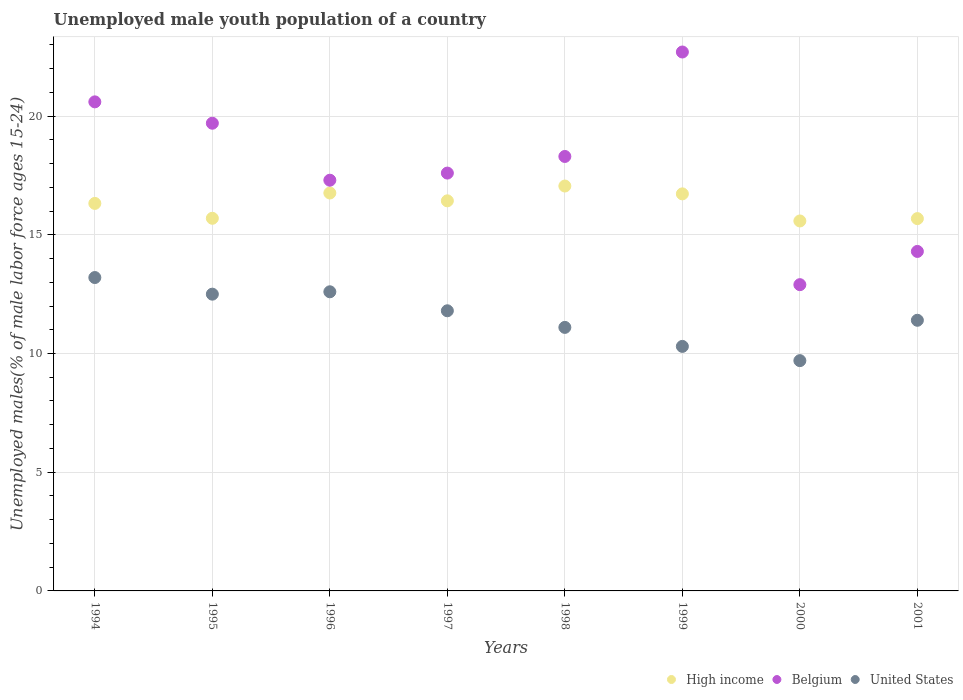How many different coloured dotlines are there?
Ensure brevity in your answer.  3. What is the percentage of unemployed male youth population in High income in 1996?
Make the answer very short. 16.76. Across all years, what is the maximum percentage of unemployed male youth population in Belgium?
Your response must be concise. 22.7. Across all years, what is the minimum percentage of unemployed male youth population in High income?
Your answer should be very brief. 15.58. In which year was the percentage of unemployed male youth population in Belgium minimum?
Your response must be concise. 2000. What is the total percentage of unemployed male youth population in United States in the graph?
Ensure brevity in your answer.  92.6. What is the difference between the percentage of unemployed male youth population in Belgium in 1994 and that in 2001?
Ensure brevity in your answer.  6.3. What is the difference between the percentage of unemployed male youth population in United States in 1995 and the percentage of unemployed male youth population in Belgium in 1996?
Ensure brevity in your answer.  -4.8. What is the average percentage of unemployed male youth population in High income per year?
Your answer should be compact. 16.28. In the year 1994, what is the difference between the percentage of unemployed male youth population in United States and percentage of unemployed male youth population in Belgium?
Provide a succinct answer. -7.4. What is the ratio of the percentage of unemployed male youth population in High income in 1994 to that in 1996?
Your answer should be compact. 0.97. What is the difference between the highest and the second highest percentage of unemployed male youth population in High income?
Give a very brief answer. 0.29. What is the difference between the highest and the lowest percentage of unemployed male youth population in Belgium?
Give a very brief answer. 9.8. In how many years, is the percentage of unemployed male youth population in United States greater than the average percentage of unemployed male youth population in United States taken over all years?
Your response must be concise. 4. Is the sum of the percentage of unemployed male youth population in Belgium in 1996 and 2001 greater than the maximum percentage of unemployed male youth population in High income across all years?
Make the answer very short. Yes. Is the percentage of unemployed male youth population in Belgium strictly less than the percentage of unemployed male youth population in United States over the years?
Offer a terse response. No. How many dotlines are there?
Give a very brief answer. 3. How many years are there in the graph?
Give a very brief answer. 8. What is the difference between two consecutive major ticks on the Y-axis?
Your response must be concise. 5. Are the values on the major ticks of Y-axis written in scientific E-notation?
Your response must be concise. No. What is the title of the graph?
Offer a very short reply. Unemployed male youth population of a country. What is the label or title of the Y-axis?
Your response must be concise. Unemployed males(% of male labor force ages 15-24). What is the Unemployed males(% of male labor force ages 15-24) of High income in 1994?
Offer a terse response. 16.32. What is the Unemployed males(% of male labor force ages 15-24) of Belgium in 1994?
Your response must be concise. 20.6. What is the Unemployed males(% of male labor force ages 15-24) in United States in 1994?
Your answer should be compact. 13.2. What is the Unemployed males(% of male labor force ages 15-24) in High income in 1995?
Give a very brief answer. 15.7. What is the Unemployed males(% of male labor force ages 15-24) in Belgium in 1995?
Make the answer very short. 19.7. What is the Unemployed males(% of male labor force ages 15-24) of United States in 1995?
Make the answer very short. 12.5. What is the Unemployed males(% of male labor force ages 15-24) in High income in 1996?
Keep it short and to the point. 16.76. What is the Unemployed males(% of male labor force ages 15-24) in Belgium in 1996?
Provide a succinct answer. 17.3. What is the Unemployed males(% of male labor force ages 15-24) of United States in 1996?
Offer a very short reply. 12.6. What is the Unemployed males(% of male labor force ages 15-24) of High income in 1997?
Offer a terse response. 16.43. What is the Unemployed males(% of male labor force ages 15-24) in Belgium in 1997?
Ensure brevity in your answer.  17.6. What is the Unemployed males(% of male labor force ages 15-24) in United States in 1997?
Your answer should be compact. 11.8. What is the Unemployed males(% of male labor force ages 15-24) in High income in 1998?
Provide a succinct answer. 17.05. What is the Unemployed males(% of male labor force ages 15-24) of Belgium in 1998?
Your answer should be compact. 18.3. What is the Unemployed males(% of male labor force ages 15-24) of United States in 1998?
Offer a terse response. 11.1. What is the Unemployed males(% of male labor force ages 15-24) of High income in 1999?
Make the answer very short. 16.72. What is the Unemployed males(% of male labor force ages 15-24) of Belgium in 1999?
Give a very brief answer. 22.7. What is the Unemployed males(% of male labor force ages 15-24) of United States in 1999?
Your response must be concise. 10.3. What is the Unemployed males(% of male labor force ages 15-24) of High income in 2000?
Make the answer very short. 15.58. What is the Unemployed males(% of male labor force ages 15-24) of Belgium in 2000?
Offer a terse response. 12.9. What is the Unemployed males(% of male labor force ages 15-24) of United States in 2000?
Your response must be concise. 9.7. What is the Unemployed males(% of male labor force ages 15-24) of High income in 2001?
Your answer should be compact. 15.68. What is the Unemployed males(% of male labor force ages 15-24) of Belgium in 2001?
Ensure brevity in your answer.  14.3. What is the Unemployed males(% of male labor force ages 15-24) in United States in 2001?
Your response must be concise. 11.4. Across all years, what is the maximum Unemployed males(% of male labor force ages 15-24) of High income?
Give a very brief answer. 17.05. Across all years, what is the maximum Unemployed males(% of male labor force ages 15-24) of Belgium?
Give a very brief answer. 22.7. Across all years, what is the maximum Unemployed males(% of male labor force ages 15-24) of United States?
Your answer should be very brief. 13.2. Across all years, what is the minimum Unemployed males(% of male labor force ages 15-24) in High income?
Your response must be concise. 15.58. Across all years, what is the minimum Unemployed males(% of male labor force ages 15-24) in Belgium?
Keep it short and to the point. 12.9. Across all years, what is the minimum Unemployed males(% of male labor force ages 15-24) in United States?
Provide a succinct answer. 9.7. What is the total Unemployed males(% of male labor force ages 15-24) in High income in the graph?
Provide a succinct answer. 130.26. What is the total Unemployed males(% of male labor force ages 15-24) of Belgium in the graph?
Offer a very short reply. 143.4. What is the total Unemployed males(% of male labor force ages 15-24) of United States in the graph?
Ensure brevity in your answer.  92.6. What is the difference between the Unemployed males(% of male labor force ages 15-24) of High income in 1994 and that in 1995?
Your answer should be very brief. 0.63. What is the difference between the Unemployed males(% of male labor force ages 15-24) of United States in 1994 and that in 1995?
Provide a short and direct response. 0.7. What is the difference between the Unemployed males(% of male labor force ages 15-24) of High income in 1994 and that in 1996?
Give a very brief answer. -0.44. What is the difference between the Unemployed males(% of male labor force ages 15-24) in High income in 1994 and that in 1997?
Your response must be concise. -0.11. What is the difference between the Unemployed males(% of male labor force ages 15-24) of United States in 1994 and that in 1997?
Ensure brevity in your answer.  1.4. What is the difference between the Unemployed males(% of male labor force ages 15-24) in High income in 1994 and that in 1998?
Provide a succinct answer. -0.73. What is the difference between the Unemployed males(% of male labor force ages 15-24) of Belgium in 1994 and that in 1998?
Provide a succinct answer. 2.3. What is the difference between the Unemployed males(% of male labor force ages 15-24) of United States in 1994 and that in 1998?
Your answer should be very brief. 2.1. What is the difference between the Unemployed males(% of male labor force ages 15-24) in High income in 1994 and that in 1999?
Provide a short and direct response. -0.4. What is the difference between the Unemployed males(% of male labor force ages 15-24) in Belgium in 1994 and that in 1999?
Give a very brief answer. -2.1. What is the difference between the Unemployed males(% of male labor force ages 15-24) in High income in 1994 and that in 2000?
Keep it short and to the point. 0.74. What is the difference between the Unemployed males(% of male labor force ages 15-24) in United States in 1994 and that in 2000?
Make the answer very short. 3.5. What is the difference between the Unemployed males(% of male labor force ages 15-24) in High income in 1994 and that in 2001?
Make the answer very short. 0.64. What is the difference between the Unemployed males(% of male labor force ages 15-24) in Belgium in 1994 and that in 2001?
Your answer should be compact. 6.3. What is the difference between the Unemployed males(% of male labor force ages 15-24) of United States in 1994 and that in 2001?
Your answer should be very brief. 1.8. What is the difference between the Unemployed males(% of male labor force ages 15-24) of High income in 1995 and that in 1996?
Make the answer very short. -1.07. What is the difference between the Unemployed males(% of male labor force ages 15-24) of United States in 1995 and that in 1996?
Your response must be concise. -0.1. What is the difference between the Unemployed males(% of male labor force ages 15-24) in High income in 1995 and that in 1997?
Make the answer very short. -0.74. What is the difference between the Unemployed males(% of male labor force ages 15-24) of Belgium in 1995 and that in 1997?
Give a very brief answer. 2.1. What is the difference between the Unemployed males(% of male labor force ages 15-24) in High income in 1995 and that in 1998?
Ensure brevity in your answer.  -1.36. What is the difference between the Unemployed males(% of male labor force ages 15-24) in United States in 1995 and that in 1998?
Give a very brief answer. 1.4. What is the difference between the Unemployed males(% of male labor force ages 15-24) of High income in 1995 and that in 1999?
Your answer should be very brief. -1.03. What is the difference between the Unemployed males(% of male labor force ages 15-24) in Belgium in 1995 and that in 1999?
Keep it short and to the point. -3. What is the difference between the Unemployed males(% of male labor force ages 15-24) of United States in 1995 and that in 1999?
Give a very brief answer. 2.2. What is the difference between the Unemployed males(% of male labor force ages 15-24) in High income in 1995 and that in 2000?
Give a very brief answer. 0.11. What is the difference between the Unemployed males(% of male labor force ages 15-24) of Belgium in 1995 and that in 2000?
Your answer should be compact. 6.8. What is the difference between the Unemployed males(% of male labor force ages 15-24) of High income in 1995 and that in 2001?
Ensure brevity in your answer.  0.01. What is the difference between the Unemployed males(% of male labor force ages 15-24) of United States in 1995 and that in 2001?
Keep it short and to the point. 1.1. What is the difference between the Unemployed males(% of male labor force ages 15-24) of High income in 1996 and that in 1997?
Provide a short and direct response. 0.33. What is the difference between the Unemployed males(% of male labor force ages 15-24) of High income in 1996 and that in 1998?
Offer a very short reply. -0.29. What is the difference between the Unemployed males(% of male labor force ages 15-24) of United States in 1996 and that in 1998?
Offer a terse response. 1.5. What is the difference between the Unemployed males(% of male labor force ages 15-24) in High income in 1996 and that in 1999?
Provide a short and direct response. 0.04. What is the difference between the Unemployed males(% of male labor force ages 15-24) in Belgium in 1996 and that in 1999?
Provide a succinct answer. -5.4. What is the difference between the Unemployed males(% of male labor force ages 15-24) of United States in 1996 and that in 1999?
Make the answer very short. 2.3. What is the difference between the Unemployed males(% of male labor force ages 15-24) in High income in 1996 and that in 2000?
Your response must be concise. 1.18. What is the difference between the Unemployed males(% of male labor force ages 15-24) in Belgium in 1996 and that in 2000?
Keep it short and to the point. 4.4. What is the difference between the Unemployed males(% of male labor force ages 15-24) of High income in 1996 and that in 2001?
Give a very brief answer. 1.08. What is the difference between the Unemployed males(% of male labor force ages 15-24) in Belgium in 1996 and that in 2001?
Provide a short and direct response. 3. What is the difference between the Unemployed males(% of male labor force ages 15-24) in United States in 1996 and that in 2001?
Your response must be concise. 1.2. What is the difference between the Unemployed males(% of male labor force ages 15-24) in High income in 1997 and that in 1998?
Your answer should be very brief. -0.62. What is the difference between the Unemployed males(% of male labor force ages 15-24) of United States in 1997 and that in 1998?
Your answer should be very brief. 0.7. What is the difference between the Unemployed males(% of male labor force ages 15-24) in High income in 1997 and that in 1999?
Give a very brief answer. -0.29. What is the difference between the Unemployed males(% of male labor force ages 15-24) of High income in 1997 and that in 2000?
Your answer should be very brief. 0.85. What is the difference between the Unemployed males(% of male labor force ages 15-24) of Belgium in 1997 and that in 2000?
Your answer should be compact. 4.7. What is the difference between the Unemployed males(% of male labor force ages 15-24) of High income in 1997 and that in 2001?
Provide a short and direct response. 0.75. What is the difference between the Unemployed males(% of male labor force ages 15-24) in Belgium in 1997 and that in 2001?
Make the answer very short. 3.3. What is the difference between the Unemployed males(% of male labor force ages 15-24) in High income in 1998 and that in 1999?
Ensure brevity in your answer.  0.33. What is the difference between the Unemployed males(% of male labor force ages 15-24) of Belgium in 1998 and that in 1999?
Your answer should be very brief. -4.4. What is the difference between the Unemployed males(% of male labor force ages 15-24) in High income in 1998 and that in 2000?
Keep it short and to the point. 1.47. What is the difference between the Unemployed males(% of male labor force ages 15-24) of High income in 1998 and that in 2001?
Make the answer very short. 1.37. What is the difference between the Unemployed males(% of male labor force ages 15-24) of United States in 1998 and that in 2001?
Offer a very short reply. -0.3. What is the difference between the Unemployed males(% of male labor force ages 15-24) of High income in 1999 and that in 2000?
Offer a terse response. 1.14. What is the difference between the Unemployed males(% of male labor force ages 15-24) of Belgium in 1999 and that in 2000?
Ensure brevity in your answer.  9.8. What is the difference between the Unemployed males(% of male labor force ages 15-24) of United States in 1999 and that in 2000?
Make the answer very short. 0.6. What is the difference between the Unemployed males(% of male labor force ages 15-24) in High income in 1999 and that in 2001?
Your response must be concise. 1.04. What is the difference between the Unemployed males(% of male labor force ages 15-24) of United States in 1999 and that in 2001?
Keep it short and to the point. -1.1. What is the difference between the Unemployed males(% of male labor force ages 15-24) in High income in 2000 and that in 2001?
Provide a short and direct response. -0.1. What is the difference between the Unemployed males(% of male labor force ages 15-24) in United States in 2000 and that in 2001?
Offer a very short reply. -1.7. What is the difference between the Unemployed males(% of male labor force ages 15-24) of High income in 1994 and the Unemployed males(% of male labor force ages 15-24) of Belgium in 1995?
Your answer should be compact. -3.38. What is the difference between the Unemployed males(% of male labor force ages 15-24) of High income in 1994 and the Unemployed males(% of male labor force ages 15-24) of United States in 1995?
Offer a terse response. 3.82. What is the difference between the Unemployed males(% of male labor force ages 15-24) of Belgium in 1994 and the Unemployed males(% of male labor force ages 15-24) of United States in 1995?
Your response must be concise. 8.1. What is the difference between the Unemployed males(% of male labor force ages 15-24) of High income in 1994 and the Unemployed males(% of male labor force ages 15-24) of Belgium in 1996?
Keep it short and to the point. -0.98. What is the difference between the Unemployed males(% of male labor force ages 15-24) in High income in 1994 and the Unemployed males(% of male labor force ages 15-24) in United States in 1996?
Provide a succinct answer. 3.72. What is the difference between the Unemployed males(% of male labor force ages 15-24) of High income in 1994 and the Unemployed males(% of male labor force ages 15-24) of Belgium in 1997?
Offer a terse response. -1.28. What is the difference between the Unemployed males(% of male labor force ages 15-24) of High income in 1994 and the Unemployed males(% of male labor force ages 15-24) of United States in 1997?
Provide a succinct answer. 4.52. What is the difference between the Unemployed males(% of male labor force ages 15-24) in High income in 1994 and the Unemployed males(% of male labor force ages 15-24) in Belgium in 1998?
Offer a terse response. -1.98. What is the difference between the Unemployed males(% of male labor force ages 15-24) in High income in 1994 and the Unemployed males(% of male labor force ages 15-24) in United States in 1998?
Provide a succinct answer. 5.22. What is the difference between the Unemployed males(% of male labor force ages 15-24) of Belgium in 1994 and the Unemployed males(% of male labor force ages 15-24) of United States in 1998?
Provide a succinct answer. 9.5. What is the difference between the Unemployed males(% of male labor force ages 15-24) of High income in 1994 and the Unemployed males(% of male labor force ages 15-24) of Belgium in 1999?
Provide a short and direct response. -6.38. What is the difference between the Unemployed males(% of male labor force ages 15-24) of High income in 1994 and the Unemployed males(% of male labor force ages 15-24) of United States in 1999?
Your response must be concise. 6.02. What is the difference between the Unemployed males(% of male labor force ages 15-24) in High income in 1994 and the Unemployed males(% of male labor force ages 15-24) in Belgium in 2000?
Provide a succinct answer. 3.42. What is the difference between the Unemployed males(% of male labor force ages 15-24) of High income in 1994 and the Unemployed males(% of male labor force ages 15-24) of United States in 2000?
Make the answer very short. 6.62. What is the difference between the Unemployed males(% of male labor force ages 15-24) in High income in 1994 and the Unemployed males(% of male labor force ages 15-24) in Belgium in 2001?
Offer a terse response. 2.02. What is the difference between the Unemployed males(% of male labor force ages 15-24) of High income in 1994 and the Unemployed males(% of male labor force ages 15-24) of United States in 2001?
Your response must be concise. 4.92. What is the difference between the Unemployed males(% of male labor force ages 15-24) in High income in 1995 and the Unemployed males(% of male labor force ages 15-24) in Belgium in 1996?
Your answer should be very brief. -1.6. What is the difference between the Unemployed males(% of male labor force ages 15-24) in High income in 1995 and the Unemployed males(% of male labor force ages 15-24) in United States in 1996?
Keep it short and to the point. 3.1. What is the difference between the Unemployed males(% of male labor force ages 15-24) in Belgium in 1995 and the Unemployed males(% of male labor force ages 15-24) in United States in 1996?
Provide a short and direct response. 7.1. What is the difference between the Unemployed males(% of male labor force ages 15-24) of High income in 1995 and the Unemployed males(% of male labor force ages 15-24) of Belgium in 1997?
Offer a terse response. -1.9. What is the difference between the Unemployed males(% of male labor force ages 15-24) of High income in 1995 and the Unemployed males(% of male labor force ages 15-24) of United States in 1997?
Provide a succinct answer. 3.9. What is the difference between the Unemployed males(% of male labor force ages 15-24) in High income in 1995 and the Unemployed males(% of male labor force ages 15-24) in Belgium in 1998?
Ensure brevity in your answer.  -2.6. What is the difference between the Unemployed males(% of male labor force ages 15-24) in High income in 1995 and the Unemployed males(% of male labor force ages 15-24) in United States in 1998?
Ensure brevity in your answer.  4.6. What is the difference between the Unemployed males(% of male labor force ages 15-24) of Belgium in 1995 and the Unemployed males(% of male labor force ages 15-24) of United States in 1998?
Ensure brevity in your answer.  8.6. What is the difference between the Unemployed males(% of male labor force ages 15-24) in High income in 1995 and the Unemployed males(% of male labor force ages 15-24) in Belgium in 1999?
Make the answer very short. -7. What is the difference between the Unemployed males(% of male labor force ages 15-24) of High income in 1995 and the Unemployed males(% of male labor force ages 15-24) of United States in 1999?
Your answer should be compact. 5.4. What is the difference between the Unemployed males(% of male labor force ages 15-24) of Belgium in 1995 and the Unemployed males(% of male labor force ages 15-24) of United States in 1999?
Ensure brevity in your answer.  9.4. What is the difference between the Unemployed males(% of male labor force ages 15-24) of High income in 1995 and the Unemployed males(% of male labor force ages 15-24) of Belgium in 2000?
Keep it short and to the point. 2.8. What is the difference between the Unemployed males(% of male labor force ages 15-24) of High income in 1995 and the Unemployed males(% of male labor force ages 15-24) of United States in 2000?
Give a very brief answer. 6. What is the difference between the Unemployed males(% of male labor force ages 15-24) of High income in 1995 and the Unemployed males(% of male labor force ages 15-24) of Belgium in 2001?
Give a very brief answer. 1.4. What is the difference between the Unemployed males(% of male labor force ages 15-24) of High income in 1995 and the Unemployed males(% of male labor force ages 15-24) of United States in 2001?
Offer a terse response. 4.3. What is the difference between the Unemployed males(% of male labor force ages 15-24) in Belgium in 1995 and the Unemployed males(% of male labor force ages 15-24) in United States in 2001?
Your answer should be compact. 8.3. What is the difference between the Unemployed males(% of male labor force ages 15-24) in High income in 1996 and the Unemployed males(% of male labor force ages 15-24) in Belgium in 1997?
Offer a very short reply. -0.84. What is the difference between the Unemployed males(% of male labor force ages 15-24) in High income in 1996 and the Unemployed males(% of male labor force ages 15-24) in United States in 1997?
Give a very brief answer. 4.96. What is the difference between the Unemployed males(% of male labor force ages 15-24) in Belgium in 1996 and the Unemployed males(% of male labor force ages 15-24) in United States in 1997?
Make the answer very short. 5.5. What is the difference between the Unemployed males(% of male labor force ages 15-24) in High income in 1996 and the Unemployed males(% of male labor force ages 15-24) in Belgium in 1998?
Your response must be concise. -1.54. What is the difference between the Unemployed males(% of male labor force ages 15-24) of High income in 1996 and the Unemployed males(% of male labor force ages 15-24) of United States in 1998?
Your response must be concise. 5.66. What is the difference between the Unemployed males(% of male labor force ages 15-24) of Belgium in 1996 and the Unemployed males(% of male labor force ages 15-24) of United States in 1998?
Provide a short and direct response. 6.2. What is the difference between the Unemployed males(% of male labor force ages 15-24) of High income in 1996 and the Unemployed males(% of male labor force ages 15-24) of Belgium in 1999?
Your answer should be compact. -5.94. What is the difference between the Unemployed males(% of male labor force ages 15-24) of High income in 1996 and the Unemployed males(% of male labor force ages 15-24) of United States in 1999?
Give a very brief answer. 6.46. What is the difference between the Unemployed males(% of male labor force ages 15-24) of Belgium in 1996 and the Unemployed males(% of male labor force ages 15-24) of United States in 1999?
Offer a very short reply. 7. What is the difference between the Unemployed males(% of male labor force ages 15-24) of High income in 1996 and the Unemployed males(% of male labor force ages 15-24) of Belgium in 2000?
Ensure brevity in your answer.  3.86. What is the difference between the Unemployed males(% of male labor force ages 15-24) in High income in 1996 and the Unemployed males(% of male labor force ages 15-24) in United States in 2000?
Your response must be concise. 7.06. What is the difference between the Unemployed males(% of male labor force ages 15-24) of High income in 1996 and the Unemployed males(% of male labor force ages 15-24) of Belgium in 2001?
Ensure brevity in your answer.  2.46. What is the difference between the Unemployed males(% of male labor force ages 15-24) in High income in 1996 and the Unemployed males(% of male labor force ages 15-24) in United States in 2001?
Your response must be concise. 5.36. What is the difference between the Unemployed males(% of male labor force ages 15-24) of High income in 1997 and the Unemployed males(% of male labor force ages 15-24) of Belgium in 1998?
Make the answer very short. -1.87. What is the difference between the Unemployed males(% of male labor force ages 15-24) in High income in 1997 and the Unemployed males(% of male labor force ages 15-24) in United States in 1998?
Give a very brief answer. 5.33. What is the difference between the Unemployed males(% of male labor force ages 15-24) in Belgium in 1997 and the Unemployed males(% of male labor force ages 15-24) in United States in 1998?
Provide a succinct answer. 6.5. What is the difference between the Unemployed males(% of male labor force ages 15-24) of High income in 1997 and the Unemployed males(% of male labor force ages 15-24) of Belgium in 1999?
Your response must be concise. -6.27. What is the difference between the Unemployed males(% of male labor force ages 15-24) in High income in 1997 and the Unemployed males(% of male labor force ages 15-24) in United States in 1999?
Your answer should be compact. 6.13. What is the difference between the Unemployed males(% of male labor force ages 15-24) in Belgium in 1997 and the Unemployed males(% of male labor force ages 15-24) in United States in 1999?
Provide a succinct answer. 7.3. What is the difference between the Unemployed males(% of male labor force ages 15-24) in High income in 1997 and the Unemployed males(% of male labor force ages 15-24) in Belgium in 2000?
Give a very brief answer. 3.53. What is the difference between the Unemployed males(% of male labor force ages 15-24) in High income in 1997 and the Unemployed males(% of male labor force ages 15-24) in United States in 2000?
Provide a succinct answer. 6.73. What is the difference between the Unemployed males(% of male labor force ages 15-24) in High income in 1997 and the Unemployed males(% of male labor force ages 15-24) in Belgium in 2001?
Ensure brevity in your answer.  2.13. What is the difference between the Unemployed males(% of male labor force ages 15-24) in High income in 1997 and the Unemployed males(% of male labor force ages 15-24) in United States in 2001?
Your answer should be compact. 5.03. What is the difference between the Unemployed males(% of male labor force ages 15-24) in Belgium in 1997 and the Unemployed males(% of male labor force ages 15-24) in United States in 2001?
Ensure brevity in your answer.  6.2. What is the difference between the Unemployed males(% of male labor force ages 15-24) in High income in 1998 and the Unemployed males(% of male labor force ages 15-24) in Belgium in 1999?
Give a very brief answer. -5.65. What is the difference between the Unemployed males(% of male labor force ages 15-24) in High income in 1998 and the Unemployed males(% of male labor force ages 15-24) in United States in 1999?
Offer a very short reply. 6.75. What is the difference between the Unemployed males(% of male labor force ages 15-24) in High income in 1998 and the Unemployed males(% of male labor force ages 15-24) in Belgium in 2000?
Offer a very short reply. 4.15. What is the difference between the Unemployed males(% of male labor force ages 15-24) of High income in 1998 and the Unemployed males(% of male labor force ages 15-24) of United States in 2000?
Provide a succinct answer. 7.35. What is the difference between the Unemployed males(% of male labor force ages 15-24) in High income in 1998 and the Unemployed males(% of male labor force ages 15-24) in Belgium in 2001?
Provide a succinct answer. 2.75. What is the difference between the Unemployed males(% of male labor force ages 15-24) of High income in 1998 and the Unemployed males(% of male labor force ages 15-24) of United States in 2001?
Provide a succinct answer. 5.65. What is the difference between the Unemployed males(% of male labor force ages 15-24) in High income in 1999 and the Unemployed males(% of male labor force ages 15-24) in Belgium in 2000?
Provide a succinct answer. 3.82. What is the difference between the Unemployed males(% of male labor force ages 15-24) of High income in 1999 and the Unemployed males(% of male labor force ages 15-24) of United States in 2000?
Provide a succinct answer. 7.02. What is the difference between the Unemployed males(% of male labor force ages 15-24) in High income in 1999 and the Unemployed males(% of male labor force ages 15-24) in Belgium in 2001?
Offer a very short reply. 2.42. What is the difference between the Unemployed males(% of male labor force ages 15-24) in High income in 1999 and the Unemployed males(% of male labor force ages 15-24) in United States in 2001?
Keep it short and to the point. 5.32. What is the difference between the Unemployed males(% of male labor force ages 15-24) in Belgium in 1999 and the Unemployed males(% of male labor force ages 15-24) in United States in 2001?
Your answer should be compact. 11.3. What is the difference between the Unemployed males(% of male labor force ages 15-24) in High income in 2000 and the Unemployed males(% of male labor force ages 15-24) in Belgium in 2001?
Offer a terse response. 1.28. What is the difference between the Unemployed males(% of male labor force ages 15-24) of High income in 2000 and the Unemployed males(% of male labor force ages 15-24) of United States in 2001?
Provide a succinct answer. 4.18. What is the average Unemployed males(% of male labor force ages 15-24) in High income per year?
Ensure brevity in your answer.  16.28. What is the average Unemployed males(% of male labor force ages 15-24) in Belgium per year?
Give a very brief answer. 17.93. What is the average Unemployed males(% of male labor force ages 15-24) of United States per year?
Offer a very short reply. 11.57. In the year 1994, what is the difference between the Unemployed males(% of male labor force ages 15-24) in High income and Unemployed males(% of male labor force ages 15-24) in Belgium?
Offer a terse response. -4.28. In the year 1994, what is the difference between the Unemployed males(% of male labor force ages 15-24) in High income and Unemployed males(% of male labor force ages 15-24) in United States?
Make the answer very short. 3.12. In the year 1994, what is the difference between the Unemployed males(% of male labor force ages 15-24) in Belgium and Unemployed males(% of male labor force ages 15-24) in United States?
Your answer should be very brief. 7.4. In the year 1995, what is the difference between the Unemployed males(% of male labor force ages 15-24) of High income and Unemployed males(% of male labor force ages 15-24) of Belgium?
Provide a short and direct response. -4. In the year 1995, what is the difference between the Unemployed males(% of male labor force ages 15-24) in High income and Unemployed males(% of male labor force ages 15-24) in United States?
Give a very brief answer. 3.2. In the year 1995, what is the difference between the Unemployed males(% of male labor force ages 15-24) of Belgium and Unemployed males(% of male labor force ages 15-24) of United States?
Keep it short and to the point. 7.2. In the year 1996, what is the difference between the Unemployed males(% of male labor force ages 15-24) in High income and Unemployed males(% of male labor force ages 15-24) in Belgium?
Give a very brief answer. -0.54. In the year 1996, what is the difference between the Unemployed males(% of male labor force ages 15-24) of High income and Unemployed males(% of male labor force ages 15-24) of United States?
Keep it short and to the point. 4.16. In the year 1996, what is the difference between the Unemployed males(% of male labor force ages 15-24) in Belgium and Unemployed males(% of male labor force ages 15-24) in United States?
Offer a terse response. 4.7. In the year 1997, what is the difference between the Unemployed males(% of male labor force ages 15-24) of High income and Unemployed males(% of male labor force ages 15-24) of Belgium?
Offer a terse response. -1.17. In the year 1997, what is the difference between the Unemployed males(% of male labor force ages 15-24) in High income and Unemployed males(% of male labor force ages 15-24) in United States?
Make the answer very short. 4.63. In the year 1997, what is the difference between the Unemployed males(% of male labor force ages 15-24) in Belgium and Unemployed males(% of male labor force ages 15-24) in United States?
Offer a terse response. 5.8. In the year 1998, what is the difference between the Unemployed males(% of male labor force ages 15-24) of High income and Unemployed males(% of male labor force ages 15-24) of Belgium?
Provide a short and direct response. -1.25. In the year 1998, what is the difference between the Unemployed males(% of male labor force ages 15-24) in High income and Unemployed males(% of male labor force ages 15-24) in United States?
Provide a short and direct response. 5.95. In the year 1998, what is the difference between the Unemployed males(% of male labor force ages 15-24) of Belgium and Unemployed males(% of male labor force ages 15-24) of United States?
Make the answer very short. 7.2. In the year 1999, what is the difference between the Unemployed males(% of male labor force ages 15-24) in High income and Unemployed males(% of male labor force ages 15-24) in Belgium?
Your answer should be very brief. -5.98. In the year 1999, what is the difference between the Unemployed males(% of male labor force ages 15-24) in High income and Unemployed males(% of male labor force ages 15-24) in United States?
Keep it short and to the point. 6.42. In the year 2000, what is the difference between the Unemployed males(% of male labor force ages 15-24) of High income and Unemployed males(% of male labor force ages 15-24) of Belgium?
Ensure brevity in your answer.  2.68. In the year 2000, what is the difference between the Unemployed males(% of male labor force ages 15-24) of High income and Unemployed males(% of male labor force ages 15-24) of United States?
Ensure brevity in your answer.  5.88. In the year 2001, what is the difference between the Unemployed males(% of male labor force ages 15-24) of High income and Unemployed males(% of male labor force ages 15-24) of Belgium?
Give a very brief answer. 1.38. In the year 2001, what is the difference between the Unemployed males(% of male labor force ages 15-24) in High income and Unemployed males(% of male labor force ages 15-24) in United States?
Keep it short and to the point. 4.28. In the year 2001, what is the difference between the Unemployed males(% of male labor force ages 15-24) in Belgium and Unemployed males(% of male labor force ages 15-24) in United States?
Offer a terse response. 2.9. What is the ratio of the Unemployed males(% of male labor force ages 15-24) of High income in 1994 to that in 1995?
Keep it short and to the point. 1.04. What is the ratio of the Unemployed males(% of male labor force ages 15-24) of Belgium in 1994 to that in 1995?
Provide a short and direct response. 1.05. What is the ratio of the Unemployed males(% of male labor force ages 15-24) of United States in 1994 to that in 1995?
Give a very brief answer. 1.06. What is the ratio of the Unemployed males(% of male labor force ages 15-24) in High income in 1994 to that in 1996?
Your response must be concise. 0.97. What is the ratio of the Unemployed males(% of male labor force ages 15-24) in Belgium in 1994 to that in 1996?
Offer a very short reply. 1.19. What is the ratio of the Unemployed males(% of male labor force ages 15-24) of United States in 1994 to that in 1996?
Your answer should be compact. 1.05. What is the ratio of the Unemployed males(% of male labor force ages 15-24) in High income in 1994 to that in 1997?
Make the answer very short. 0.99. What is the ratio of the Unemployed males(% of male labor force ages 15-24) of Belgium in 1994 to that in 1997?
Make the answer very short. 1.17. What is the ratio of the Unemployed males(% of male labor force ages 15-24) in United States in 1994 to that in 1997?
Make the answer very short. 1.12. What is the ratio of the Unemployed males(% of male labor force ages 15-24) in High income in 1994 to that in 1998?
Provide a succinct answer. 0.96. What is the ratio of the Unemployed males(% of male labor force ages 15-24) in Belgium in 1994 to that in 1998?
Give a very brief answer. 1.13. What is the ratio of the Unemployed males(% of male labor force ages 15-24) in United States in 1994 to that in 1998?
Give a very brief answer. 1.19. What is the ratio of the Unemployed males(% of male labor force ages 15-24) of High income in 1994 to that in 1999?
Keep it short and to the point. 0.98. What is the ratio of the Unemployed males(% of male labor force ages 15-24) in Belgium in 1994 to that in 1999?
Offer a terse response. 0.91. What is the ratio of the Unemployed males(% of male labor force ages 15-24) of United States in 1994 to that in 1999?
Offer a terse response. 1.28. What is the ratio of the Unemployed males(% of male labor force ages 15-24) of High income in 1994 to that in 2000?
Offer a very short reply. 1.05. What is the ratio of the Unemployed males(% of male labor force ages 15-24) of Belgium in 1994 to that in 2000?
Make the answer very short. 1.6. What is the ratio of the Unemployed males(% of male labor force ages 15-24) of United States in 1994 to that in 2000?
Keep it short and to the point. 1.36. What is the ratio of the Unemployed males(% of male labor force ages 15-24) in High income in 1994 to that in 2001?
Offer a very short reply. 1.04. What is the ratio of the Unemployed males(% of male labor force ages 15-24) of Belgium in 1994 to that in 2001?
Your answer should be very brief. 1.44. What is the ratio of the Unemployed males(% of male labor force ages 15-24) in United States in 1994 to that in 2001?
Keep it short and to the point. 1.16. What is the ratio of the Unemployed males(% of male labor force ages 15-24) in High income in 1995 to that in 1996?
Provide a short and direct response. 0.94. What is the ratio of the Unemployed males(% of male labor force ages 15-24) of Belgium in 1995 to that in 1996?
Keep it short and to the point. 1.14. What is the ratio of the Unemployed males(% of male labor force ages 15-24) of High income in 1995 to that in 1997?
Your response must be concise. 0.96. What is the ratio of the Unemployed males(% of male labor force ages 15-24) of Belgium in 1995 to that in 1997?
Provide a succinct answer. 1.12. What is the ratio of the Unemployed males(% of male labor force ages 15-24) of United States in 1995 to that in 1997?
Give a very brief answer. 1.06. What is the ratio of the Unemployed males(% of male labor force ages 15-24) in High income in 1995 to that in 1998?
Keep it short and to the point. 0.92. What is the ratio of the Unemployed males(% of male labor force ages 15-24) of Belgium in 1995 to that in 1998?
Provide a succinct answer. 1.08. What is the ratio of the Unemployed males(% of male labor force ages 15-24) of United States in 1995 to that in 1998?
Provide a succinct answer. 1.13. What is the ratio of the Unemployed males(% of male labor force ages 15-24) of High income in 1995 to that in 1999?
Ensure brevity in your answer.  0.94. What is the ratio of the Unemployed males(% of male labor force ages 15-24) in Belgium in 1995 to that in 1999?
Your response must be concise. 0.87. What is the ratio of the Unemployed males(% of male labor force ages 15-24) of United States in 1995 to that in 1999?
Your answer should be compact. 1.21. What is the ratio of the Unemployed males(% of male labor force ages 15-24) of Belgium in 1995 to that in 2000?
Give a very brief answer. 1.53. What is the ratio of the Unemployed males(% of male labor force ages 15-24) of United States in 1995 to that in 2000?
Your answer should be very brief. 1.29. What is the ratio of the Unemployed males(% of male labor force ages 15-24) of High income in 1995 to that in 2001?
Offer a very short reply. 1. What is the ratio of the Unemployed males(% of male labor force ages 15-24) of Belgium in 1995 to that in 2001?
Make the answer very short. 1.38. What is the ratio of the Unemployed males(% of male labor force ages 15-24) in United States in 1995 to that in 2001?
Offer a very short reply. 1.1. What is the ratio of the Unemployed males(% of male labor force ages 15-24) in High income in 1996 to that in 1997?
Offer a very short reply. 1.02. What is the ratio of the Unemployed males(% of male labor force ages 15-24) in Belgium in 1996 to that in 1997?
Keep it short and to the point. 0.98. What is the ratio of the Unemployed males(% of male labor force ages 15-24) of United States in 1996 to that in 1997?
Offer a very short reply. 1.07. What is the ratio of the Unemployed males(% of male labor force ages 15-24) of High income in 1996 to that in 1998?
Make the answer very short. 0.98. What is the ratio of the Unemployed males(% of male labor force ages 15-24) of Belgium in 1996 to that in 1998?
Offer a terse response. 0.95. What is the ratio of the Unemployed males(% of male labor force ages 15-24) in United States in 1996 to that in 1998?
Your answer should be compact. 1.14. What is the ratio of the Unemployed males(% of male labor force ages 15-24) of Belgium in 1996 to that in 1999?
Provide a succinct answer. 0.76. What is the ratio of the Unemployed males(% of male labor force ages 15-24) of United States in 1996 to that in 1999?
Offer a very short reply. 1.22. What is the ratio of the Unemployed males(% of male labor force ages 15-24) of High income in 1996 to that in 2000?
Provide a short and direct response. 1.08. What is the ratio of the Unemployed males(% of male labor force ages 15-24) in Belgium in 1996 to that in 2000?
Ensure brevity in your answer.  1.34. What is the ratio of the Unemployed males(% of male labor force ages 15-24) of United States in 1996 to that in 2000?
Keep it short and to the point. 1.3. What is the ratio of the Unemployed males(% of male labor force ages 15-24) in High income in 1996 to that in 2001?
Make the answer very short. 1.07. What is the ratio of the Unemployed males(% of male labor force ages 15-24) in Belgium in 1996 to that in 2001?
Your answer should be compact. 1.21. What is the ratio of the Unemployed males(% of male labor force ages 15-24) in United States in 1996 to that in 2001?
Offer a very short reply. 1.11. What is the ratio of the Unemployed males(% of male labor force ages 15-24) of High income in 1997 to that in 1998?
Offer a terse response. 0.96. What is the ratio of the Unemployed males(% of male labor force ages 15-24) in Belgium in 1997 to that in 1998?
Keep it short and to the point. 0.96. What is the ratio of the Unemployed males(% of male labor force ages 15-24) of United States in 1997 to that in 1998?
Offer a terse response. 1.06. What is the ratio of the Unemployed males(% of male labor force ages 15-24) in High income in 1997 to that in 1999?
Provide a short and direct response. 0.98. What is the ratio of the Unemployed males(% of male labor force ages 15-24) of Belgium in 1997 to that in 1999?
Your answer should be compact. 0.78. What is the ratio of the Unemployed males(% of male labor force ages 15-24) in United States in 1997 to that in 1999?
Your answer should be very brief. 1.15. What is the ratio of the Unemployed males(% of male labor force ages 15-24) in High income in 1997 to that in 2000?
Your answer should be compact. 1.05. What is the ratio of the Unemployed males(% of male labor force ages 15-24) of Belgium in 1997 to that in 2000?
Your answer should be very brief. 1.36. What is the ratio of the Unemployed males(% of male labor force ages 15-24) of United States in 1997 to that in 2000?
Give a very brief answer. 1.22. What is the ratio of the Unemployed males(% of male labor force ages 15-24) in High income in 1997 to that in 2001?
Provide a short and direct response. 1.05. What is the ratio of the Unemployed males(% of male labor force ages 15-24) in Belgium in 1997 to that in 2001?
Make the answer very short. 1.23. What is the ratio of the Unemployed males(% of male labor force ages 15-24) of United States in 1997 to that in 2001?
Offer a terse response. 1.04. What is the ratio of the Unemployed males(% of male labor force ages 15-24) of High income in 1998 to that in 1999?
Offer a terse response. 1.02. What is the ratio of the Unemployed males(% of male labor force ages 15-24) in Belgium in 1998 to that in 1999?
Keep it short and to the point. 0.81. What is the ratio of the Unemployed males(% of male labor force ages 15-24) of United States in 1998 to that in 1999?
Offer a terse response. 1.08. What is the ratio of the Unemployed males(% of male labor force ages 15-24) of High income in 1998 to that in 2000?
Offer a terse response. 1.09. What is the ratio of the Unemployed males(% of male labor force ages 15-24) in Belgium in 1998 to that in 2000?
Provide a succinct answer. 1.42. What is the ratio of the Unemployed males(% of male labor force ages 15-24) of United States in 1998 to that in 2000?
Offer a very short reply. 1.14. What is the ratio of the Unemployed males(% of male labor force ages 15-24) in High income in 1998 to that in 2001?
Your answer should be very brief. 1.09. What is the ratio of the Unemployed males(% of male labor force ages 15-24) in Belgium in 1998 to that in 2001?
Offer a very short reply. 1.28. What is the ratio of the Unemployed males(% of male labor force ages 15-24) in United States in 1998 to that in 2001?
Make the answer very short. 0.97. What is the ratio of the Unemployed males(% of male labor force ages 15-24) in High income in 1999 to that in 2000?
Offer a very short reply. 1.07. What is the ratio of the Unemployed males(% of male labor force ages 15-24) of Belgium in 1999 to that in 2000?
Your response must be concise. 1.76. What is the ratio of the Unemployed males(% of male labor force ages 15-24) in United States in 1999 to that in 2000?
Your response must be concise. 1.06. What is the ratio of the Unemployed males(% of male labor force ages 15-24) of High income in 1999 to that in 2001?
Offer a terse response. 1.07. What is the ratio of the Unemployed males(% of male labor force ages 15-24) in Belgium in 1999 to that in 2001?
Your response must be concise. 1.59. What is the ratio of the Unemployed males(% of male labor force ages 15-24) of United States in 1999 to that in 2001?
Ensure brevity in your answer.  0.9. What is the ratio of the Unemployed males(% of male labor force ages 15-24) of High income in 2000 to that in 2001?
Your answer should be very brief. 0.99. What is the ratio of the Unemployed males(% of male labor force ages 15-24) of Belgium in 2000 to that in 2001?
Give a very brief answer. 0.9. What is the ratio of the Unemployed males(% of male labor force ages 15-24) in United States in 2000 to that in 2001?
Provide a short and direct response. 0.85. What is the difference between the highest and the second highest Unemployed males(% of male labor force ages 15-24) in High income?
Make the answer very short. 0.29. What is the difference between the highest and the second highest Unemployed males(% of male labor force ages 15-24) in Belgium?
Your answer should be very brief. 2.1. What is the difference between the highest and the second highest Unemployed males(% of male labor force ages 15-24) of United States?
Offer a very short reply. 0.6. What is the difference between the highest and the lowest Unemployed males(% of male labor force ages 15-24) in High income?
Give a very brief answer. 1.47. What is the difference between the highest and the lowest Unemployed males(% of male labor force ages 15-24) of Belgium?
Provide a succinct answer. 9.8. What is the difference between the highest and the lowest Unemployed males(% of male labor force ages 15-24) in United States?
Your answer should be compact. 3.5. 